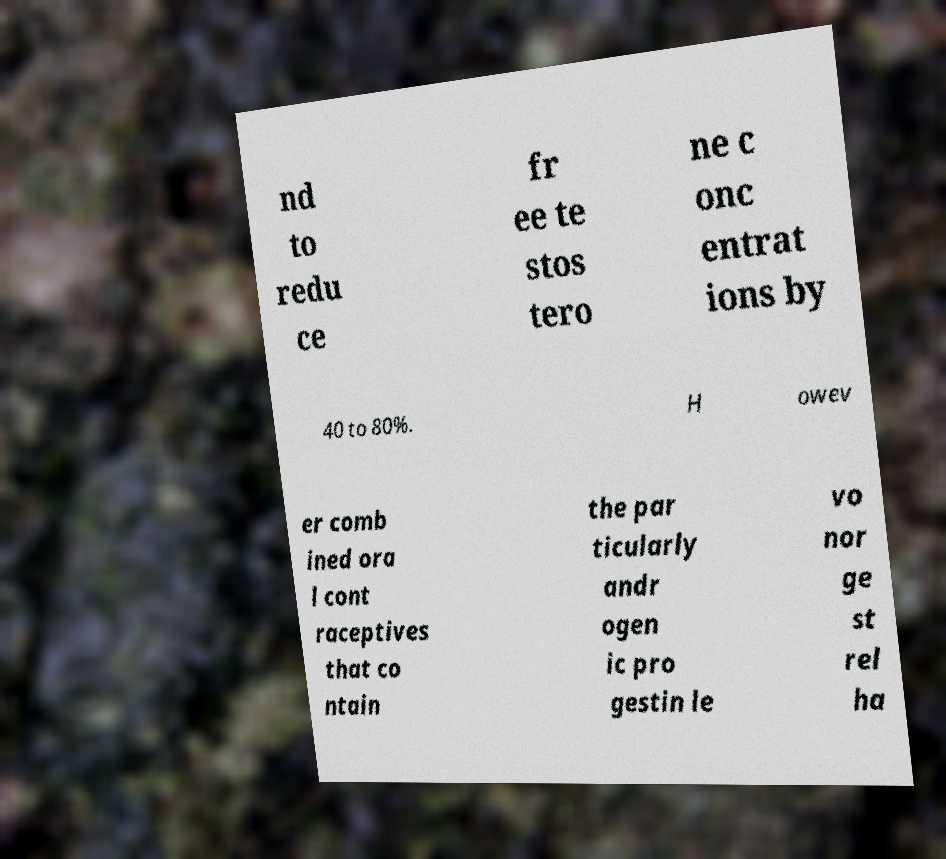Could you extract and type out the text from this image? nd to redu ce fr ee te stos tero ne c onc entrat ions by 40 to 80%. H owev er comb ined ora l cont raceptives that co ntain the par ticularly andr ogen ic pro gestin le vo nor ge st rel ha 